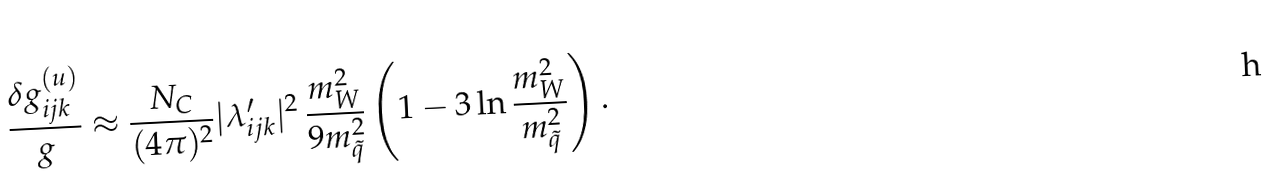Convert formula to latex. <formula><loc_0><loc_0><loc_500><loc_500>\frac { \delta g _ { i j k } ^ { ( u ) } } { g } \approx \frac { N _ { C } } { ( 4 \pi ) ^ { 2 } } | \lambda ^ { \prime } _ { i j k } | ^ { 2 } \, \frac { m _ { W } ^ { 2 } } { 9 m ^ { 2 } _ { \tilde { q } } } \left ( 1 - 3 \ln \frac { m _ { W } ^ { 2 } } { m ^ { 2 } _ { \tilde { q } } } \right ) .</formula> 